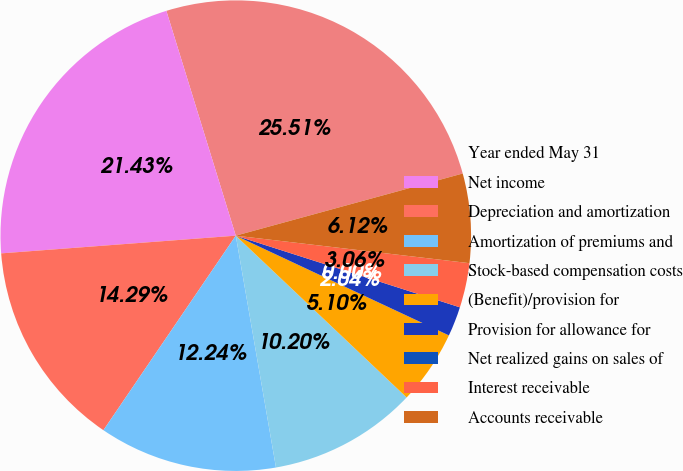<chart> <loc_0><loc_0><loc_500><loc_500><pie_chart><fcel>Year ended May 31<fcel>Net income<fcel>Depreciation and amortization<fcel>Amortization of premiums and<fcel>Stock-based compensation costs<fcel>(Benefit)/provision for<fcel>Provision for allowance for<fcel>Net realized gains on sales of<fcel>Interest receivable<fcel>Accounts receivable<nl><fcel>25.51%<fcel>21.43%<fcel>14.29%<fcel>12.24%<fcel>10.2%<fcel>5.1%<fcel>2.04%<fcel>0.0%<fcel>3.06%<fcel>6.12%<nl></chart> 